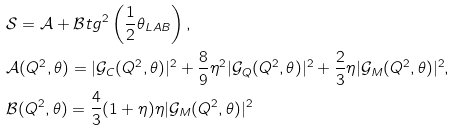Convert formula to latex. <formula><loc_0><loc_0><loc_500><loc_500>& \mathcal { S } = \mathcal { A } + \mathcal { B } t g ^ { 2 } \left ( \frac { 1 } { 2 } \theta _ { L A B } \right ) , \\ & \mathcal { A } ( Q ^ { 2 } , \theta ) = | \mathcal { G } _ { C } ( Q ^ { 2 } , \theta ) | ^ { 2 } + \frac { 8 } { 9 } \eta ^ { 2 } | \mathcal { G } _ { Q } ( Q ^ { 2 } , \theta ) | ^ { 2 } + \frac { 2 } { 3 } \eta | \mathcal { G } _ { M } ( Q ^ { 2 } , \theta ) | ^ { 2 } , \\ & \mathcal { B } ( Q ^ { 2 } , \theta ) = \frac { 4 } { 3 } ( 1 + \eta ) \eta | \mathcal { G } _ { M } ( Q ^ { 2 } , \theta ) | ^ { 2 }</formula> 